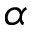<formula> <loc_0><loc_0><loc_500><loc_500>\alpha</formula> 